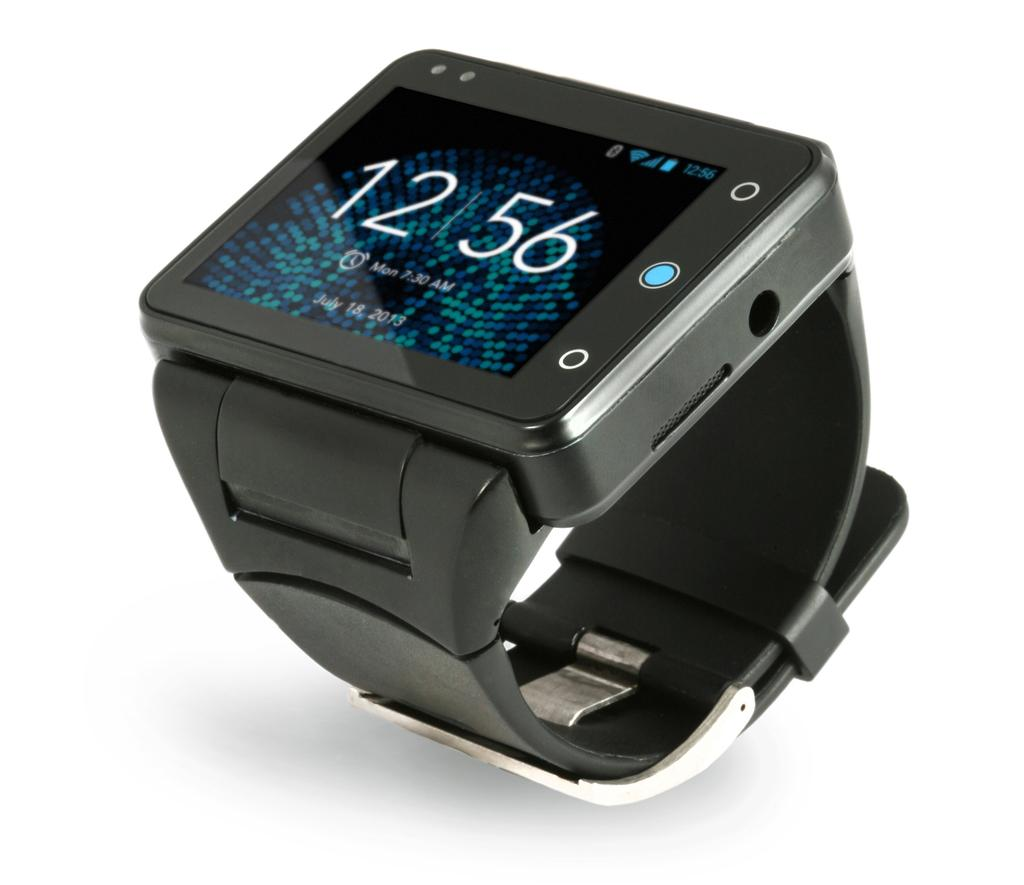<image>
Write a terse but informative summary of the picture. A square faced smart watch with the time showing 12:56 and date of July 18, 2013. 